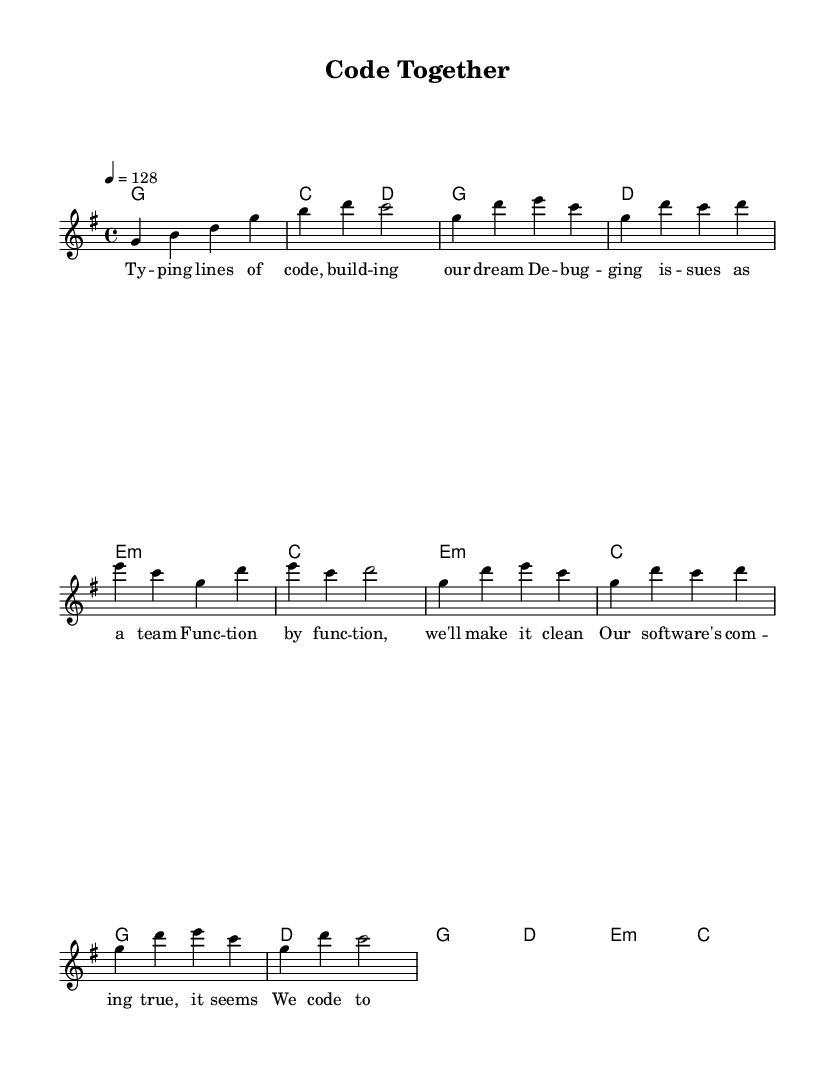What is the key signature of this music? The key signature is G major, which has one sharp (F#). It can be seen at the beginning of the staff next to the treble clef.
Answer: G major What is the time signature of this music? The time signature is 4/4, indicating four beats per measure with the quarter note getting one beat. This can be determined by looking at the notation near the beginning of the score.
Answer: 4/4 What is the tempo marking of this music? The tempo marking is 128 BPM (beats per minute), as shown at the start of the score. This means the tempo is brisk, ideal for energetic K-Pop tracks.
Answer: 128 How many measures are in the chorus section? There are four measures in the chorus section, which can be counted by examining the notation specifically under the chorus lyrics.
Answer: 4 What is the lyrical theme of this song? The lyrical theme revolves around software development and teamwork, as the lyrics emphasize coding, debugging, and working together to achieve a common goal. This can be inferred from the content of the lyrics themselves.
Answer: Teamwork Which musical section contains the lyrics about debugging? The lyrics about debugging are found in the verse section, as indicated by their placement alongside the corresponding melody and harmony lines.
Answer: Verse What type of harmony is used in the pre-chorus? The harmony used in the pre-chorus is minor, specifically E minor is indicated in the chord names. This creates a contrast with the major harmonies present in other sections, adding emotional depth to the song.
Answer: Minor 